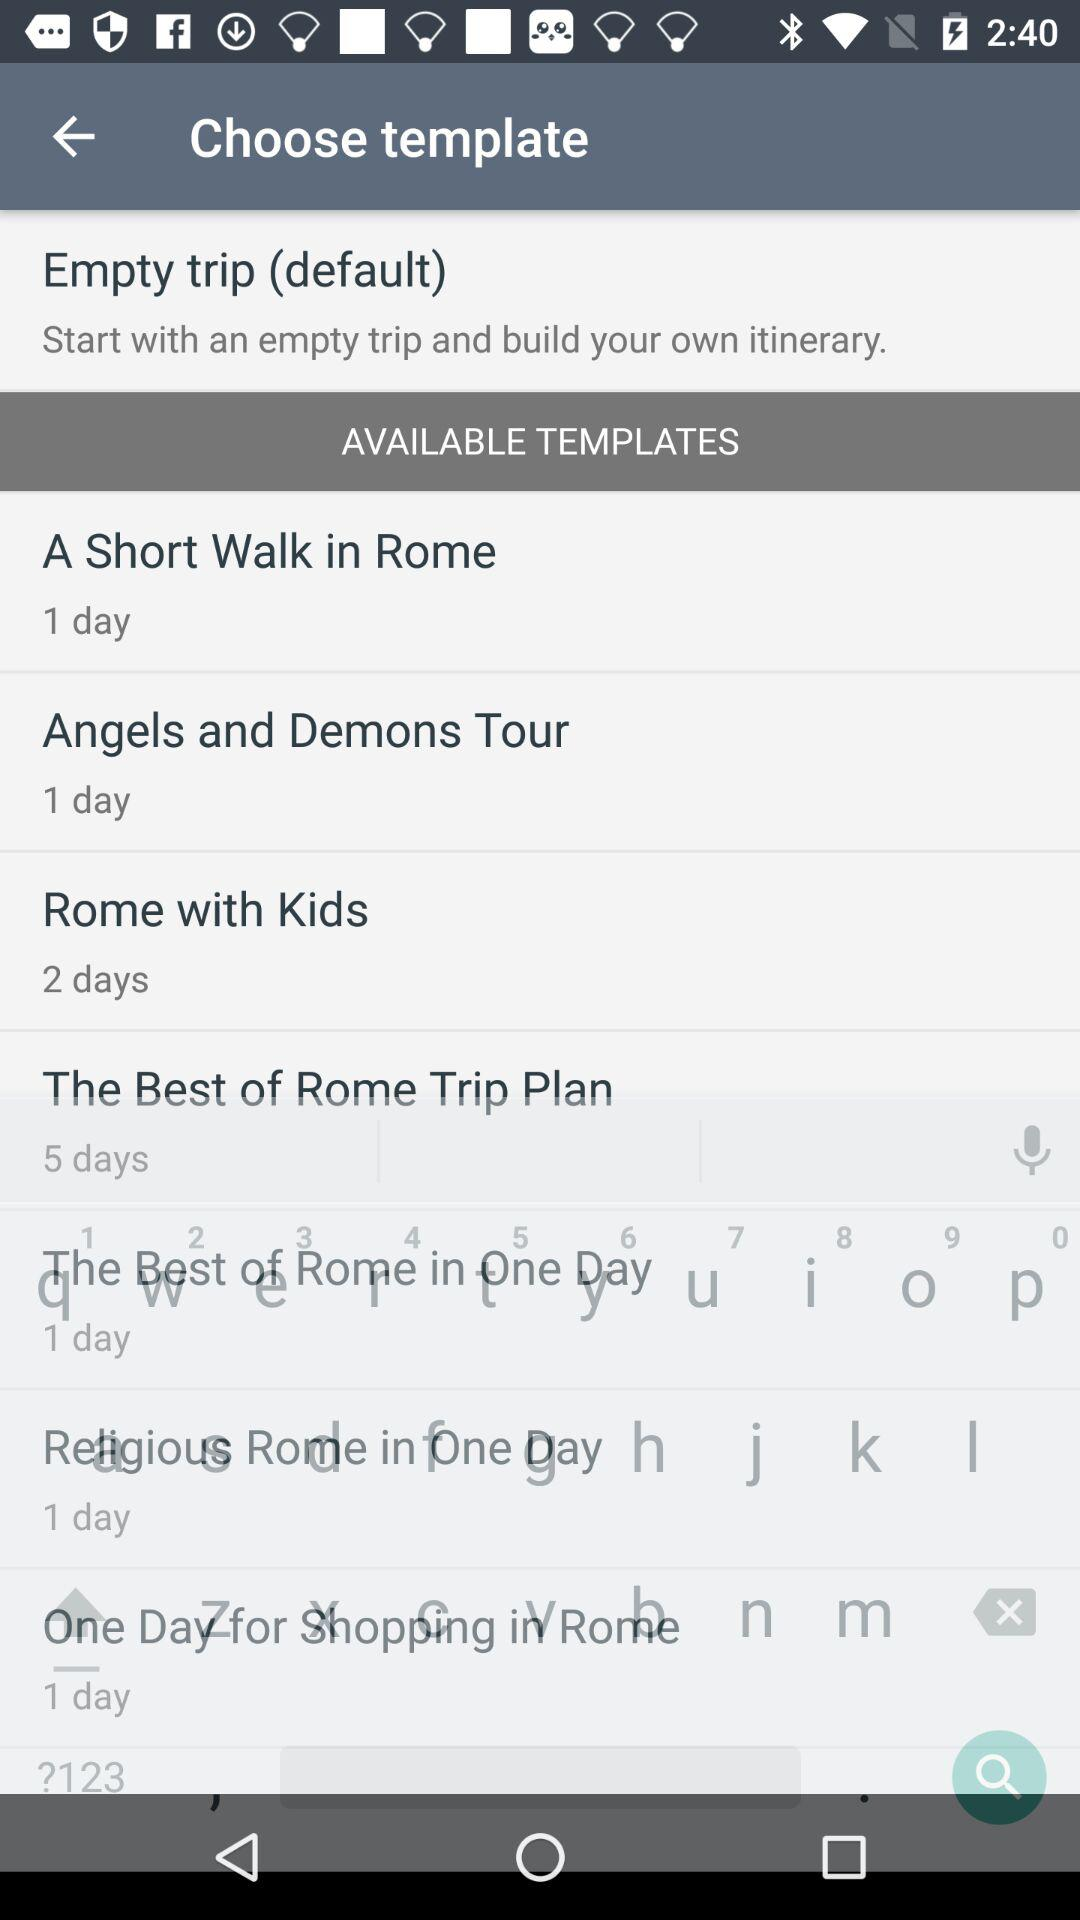For how long is the "A Short Walk in Rome" template available? The "A Short Walk in Rome" template is available for 1 day. 